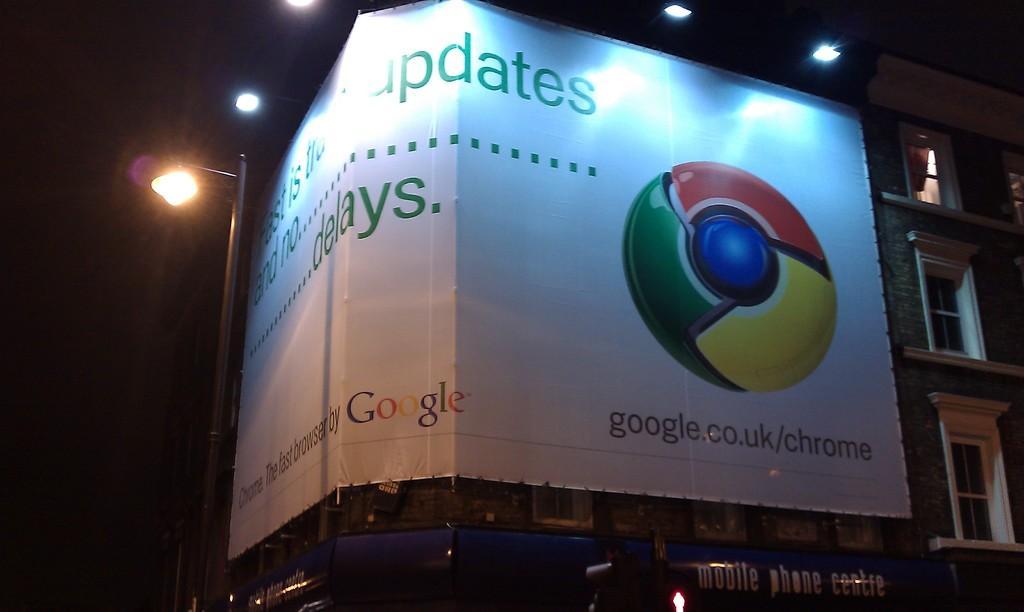Could you give a brief overview of what you see in this image? In this image, we can see a banner with some text and a logo is placed on the building. In the background, there are lights and we can see a pole. At the bottom, there are boards. 